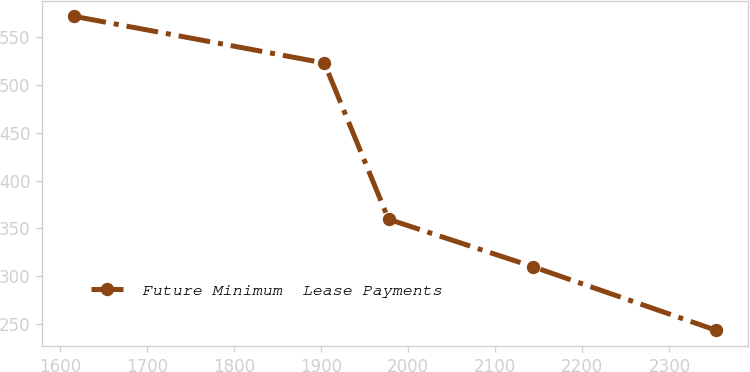<chart> <loc_0><loc_0><loc_500><loc_500><line_chart><ecel><fcel>Future Minimum  Lease Payments<nl><fcel>1616.37<fcel>571.37<nl><fcel>1903.52<fcel>522.66<nl><fcel>1977.27<fcel>359.62<nl><fcel>2143.04<fcel>310.13<nl><fcel>2353.87<fcel>243.66<nl></chart> 